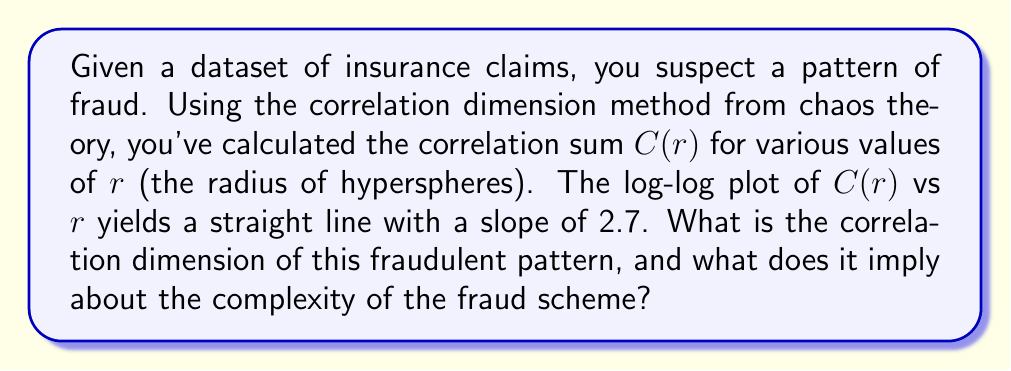Can you solve this math problem? To determine the correlation dimension and interpret its meaning, we follow these steps:

1. Recall that the correlation dimension $D_2$ is defined as:

   $$D_2 = \lim_{r \to 0} \frac{\log C(r)}{\log r}$$

2. In practice, we estimate $D_2$ by plotting $\log C(r)$ against $\log r$ and measuring the slope of the linear region.

3. Given information: The slope of the log-log plot is 2.7.

4. The slope of this log-log plot directly corresponds to the correlation dimension $D_2$. Therefore:

   $$D_2 = 2.7$$

5. Interpretation:
   - A non-integer dimension indicates a fractal structure in the data.
   - $D_2 = 2.7$ suggests that the fraud pattern is more complex than a 2D surface but less complex than a full 3D volume.
   - This implies that the fraudsters are using a sophisticated scheme that involves multiple interdependent factors, but not utilizing the full complexity of a three-dimensional strategy.

6. For an insurance agent, this means:
   - The fraud is not simple or easily detectable.
   - It's more complex than basic two-factor schemes (e.g., inflating repair costs and claim frequency).
   - However, it's not as complex as it could be, suggesting that with careful analysis, patterns could be identified and preventive measures implemented.
Answer: $D_2 = 2.7$; indicates a complex, multi-factor fraud scheme. 